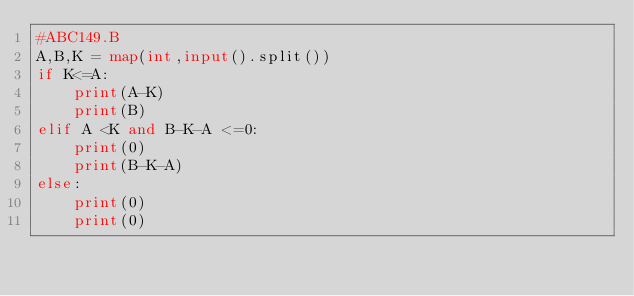Convert code to text. <code><loc_0><loc_0><loc_500><loc_500><_Python_>#ABC149.B
A,B,K = map(int,input().split())
if K<=A:
    print(A-K)
    print(B)
elif A <K and B-K-A <=0:
    print(0)
    print(B-K-A)
else:
    print(0)
    print(0)</code> 